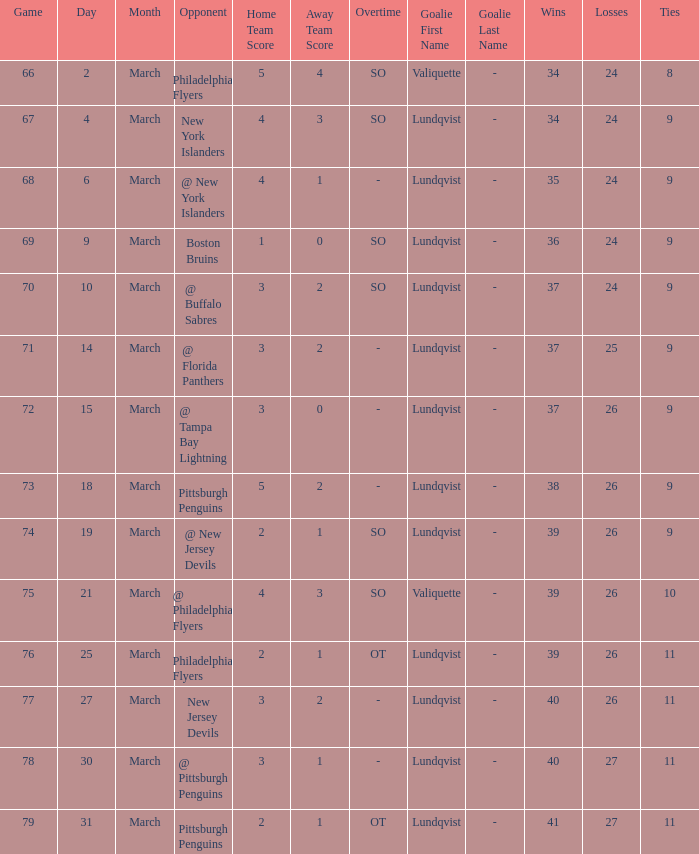Which opponent's game was less than 76 when the march was 10? @ Buffalo Sabres. 